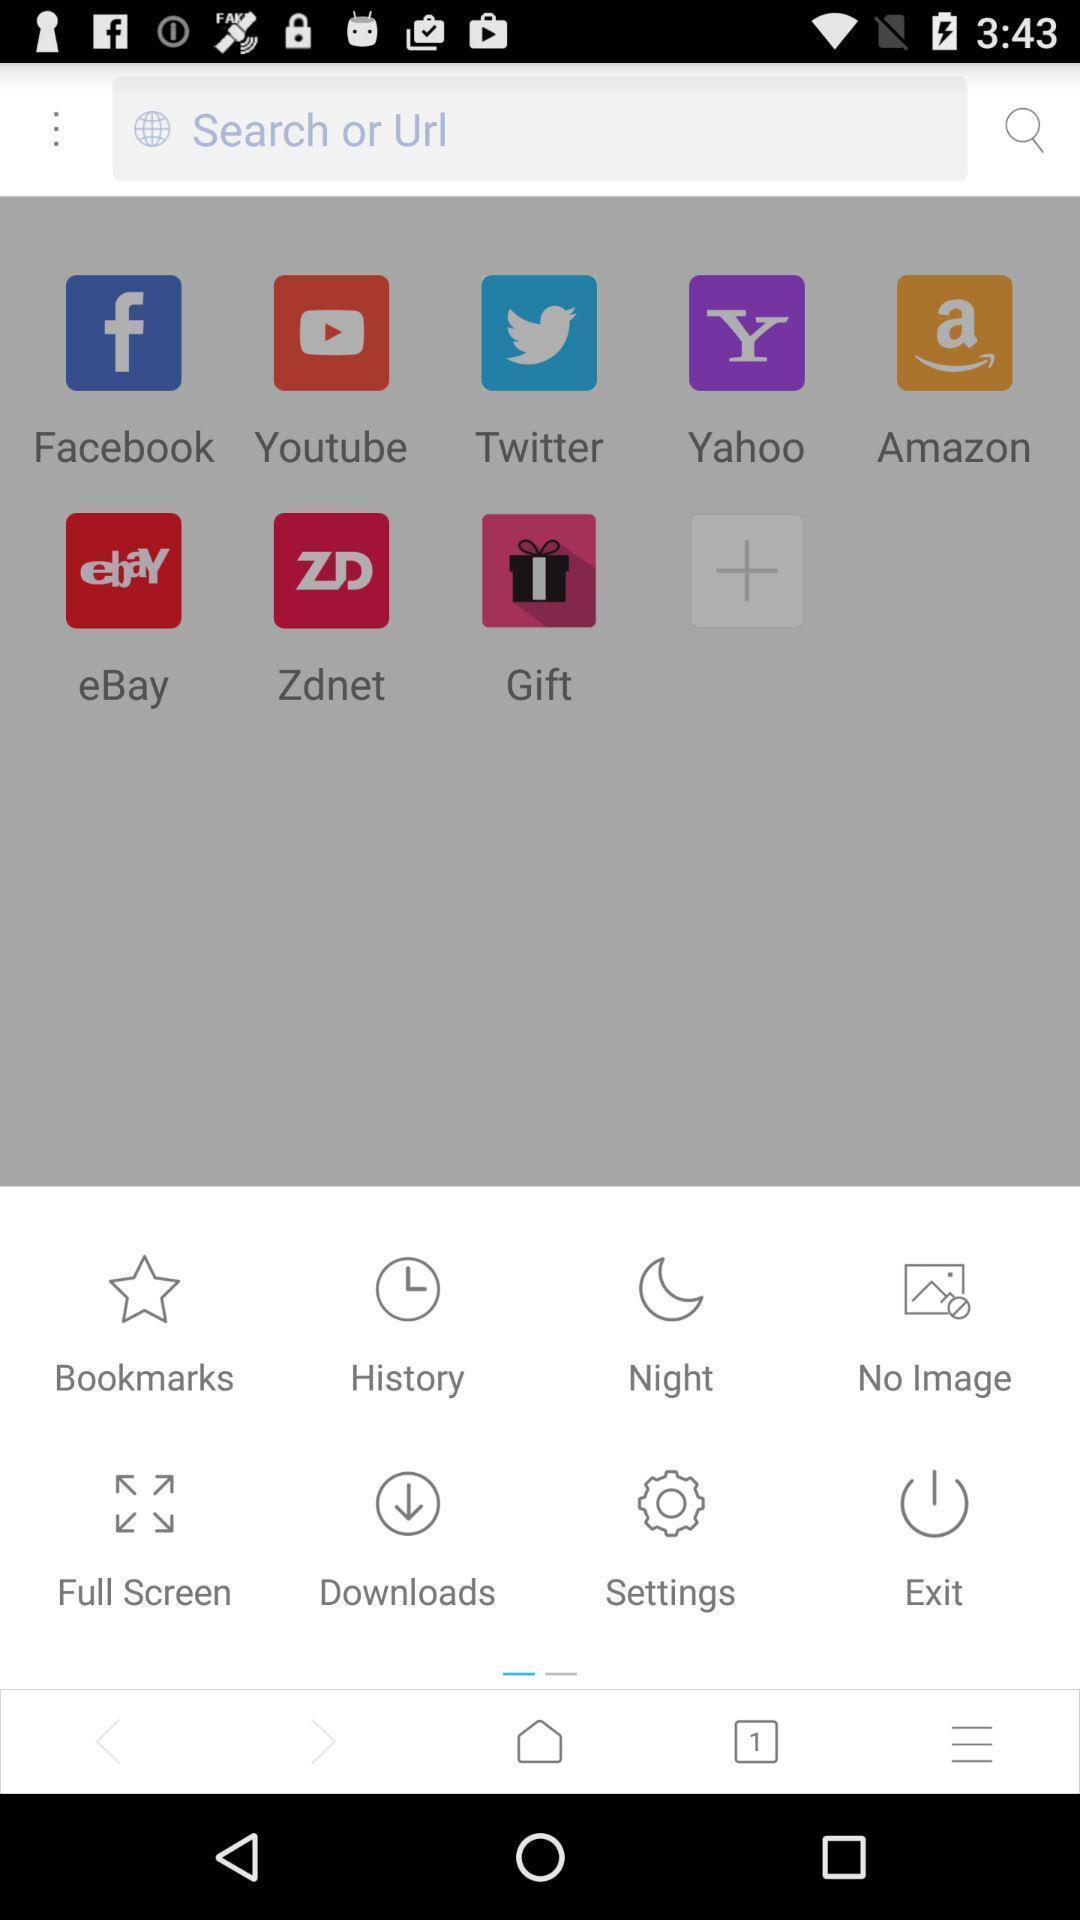Describe the key features of this screenshot. Search bar to type a url in a browser. 